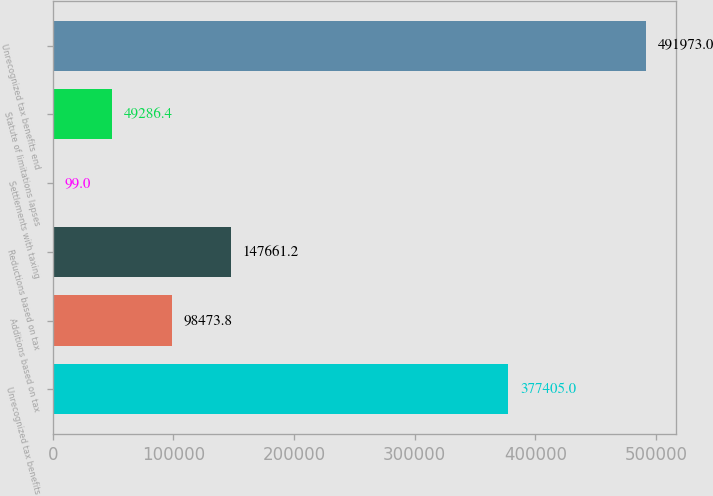Convert chart to OTSL. <chart><loc_0><loc_0><loc_500><loc_500><bar_chart><fcel>Unrecognized tax benefits<fcel>Additions based on tax<fcel>Reductions based on tax<fcel>Settlements with taxing<fcel>Statute of limitations lapses<fcel>Unrecognized tax benefits end<nl><fcel>377405<fcel>98473.8<fcel>147661<fcel>99<fcel>49286.4<fcel>491973<nl></chart> 